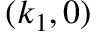<formula> <loc_0><loc_0><loc_500><loc_500>( k _ { 1 } , 0 )</formula> 